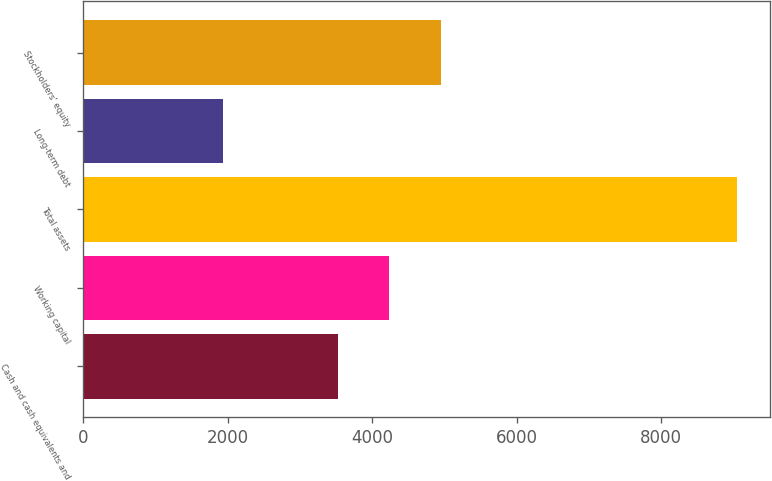Convert chart to OTSL. <chart><loc_0><loc_0><loc_500><loc_500><bar_chart><fcel>Cash and cash equivalents and<fcel>Working capital<fcel>Total assets<fcel>Long-term debt<fcel>Stockholders' equity<nl><fcel>3527<fcel>4239.5<fcel>9057<fcel>1932<fcel>4952<nl></chart> 